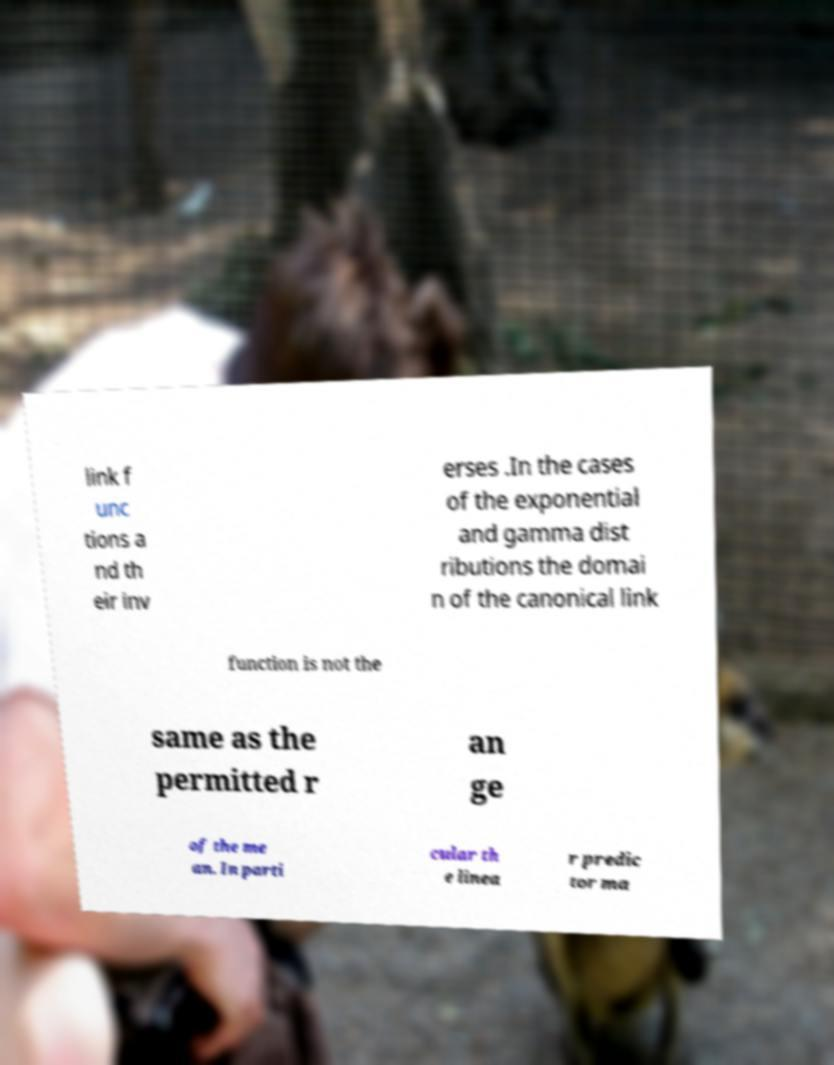I need the written content from this picture converted into text. Can you do that? link f unc tions a nd th eir inv erses .In the cases of the exponential and gamma dist ributions the domai n of the canonical link function is not the same as the permitted r an ge of the me an. In parti cular th e linea r predic tor ma 